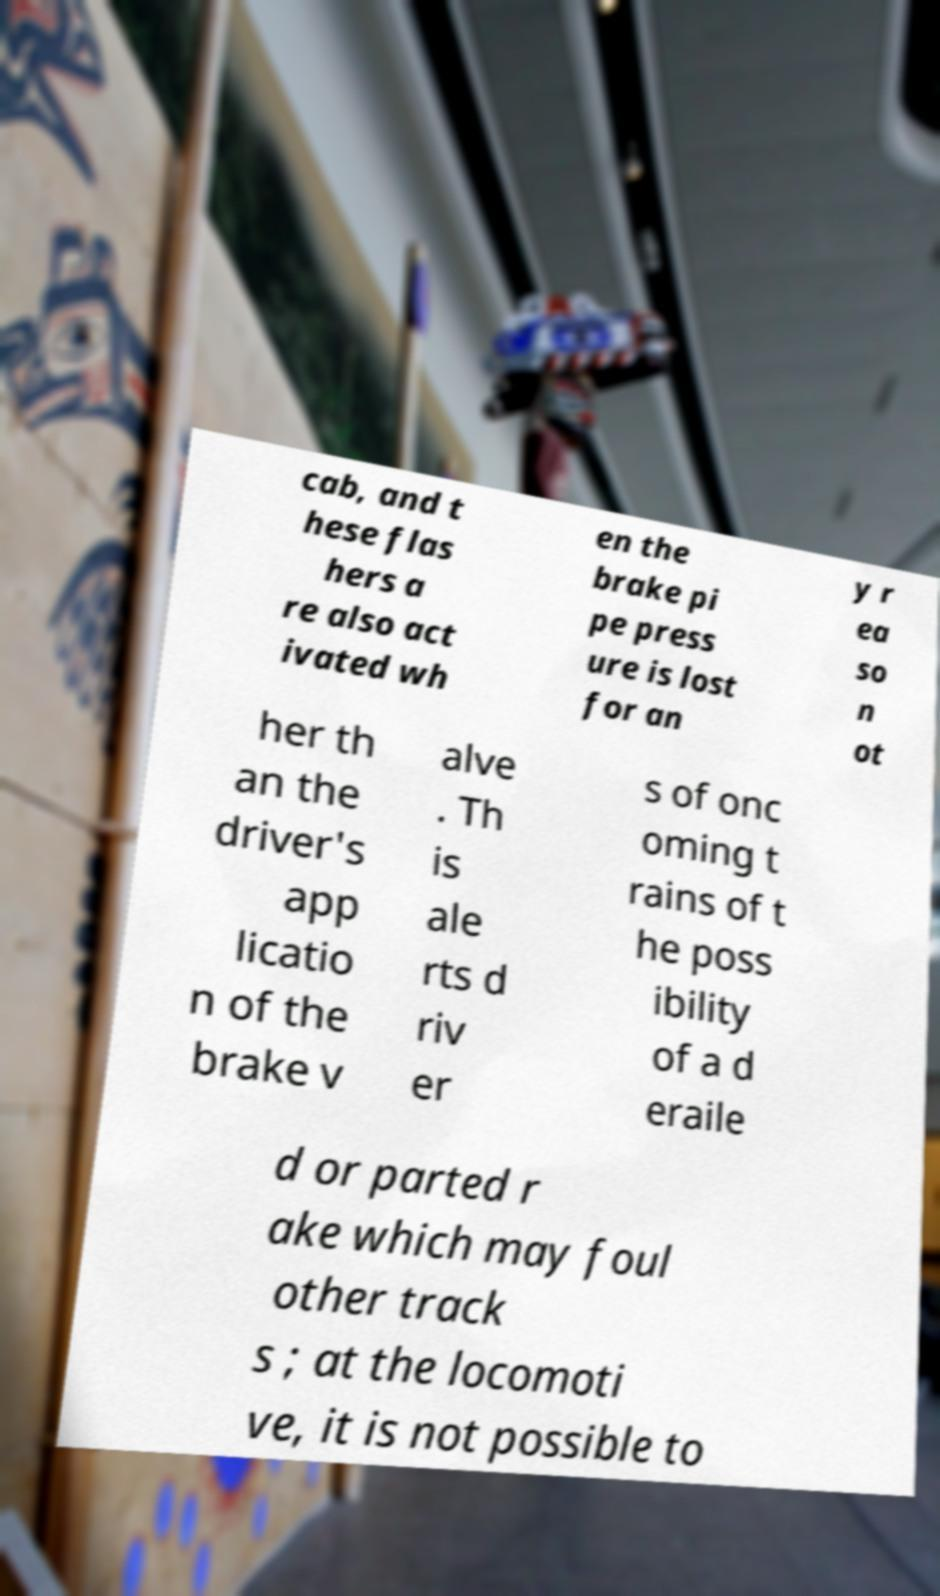For documentation purposes, I need the text within this image transcribed. Could you provide that? cab, and t hese flas hers a re also act ivated wh en the brake pi pe press ure is lost for an y r ea so n ot her th an the driver's app licatio n of the brake v alve . Th is ale rts d riv er s of onc oming t rains of t he poss ibility of a d eraile d or parted r ake which may foul other track s ; at the locomoti ve, it is not possible to 